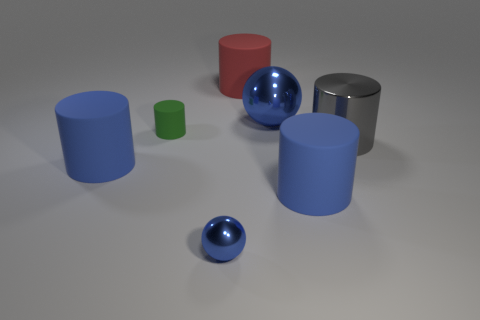Subtract all large metallic cylinders. How many cylinders are left? 4 Add 1 small cyan cylinders. How many objects exist? 8 Subtract all green cylinders. How many cylinders are left? 4 Subtract 0 purple cylinders. How many objects are left? 7 Subtract all cylinders. How many objects are left? 2 Subtract 3 cylinders. How many cylinders are left? 2 Subtract all brown spheres. Subtract all purple cubes. How many spheres are left? 2 Subtract all brown blocks. How many green cylinders are left? 1 Subtract all small matte objects. Subtract all big balls. How many objects are left? 5 Add 2 green objects. How many green objects are left? 3 